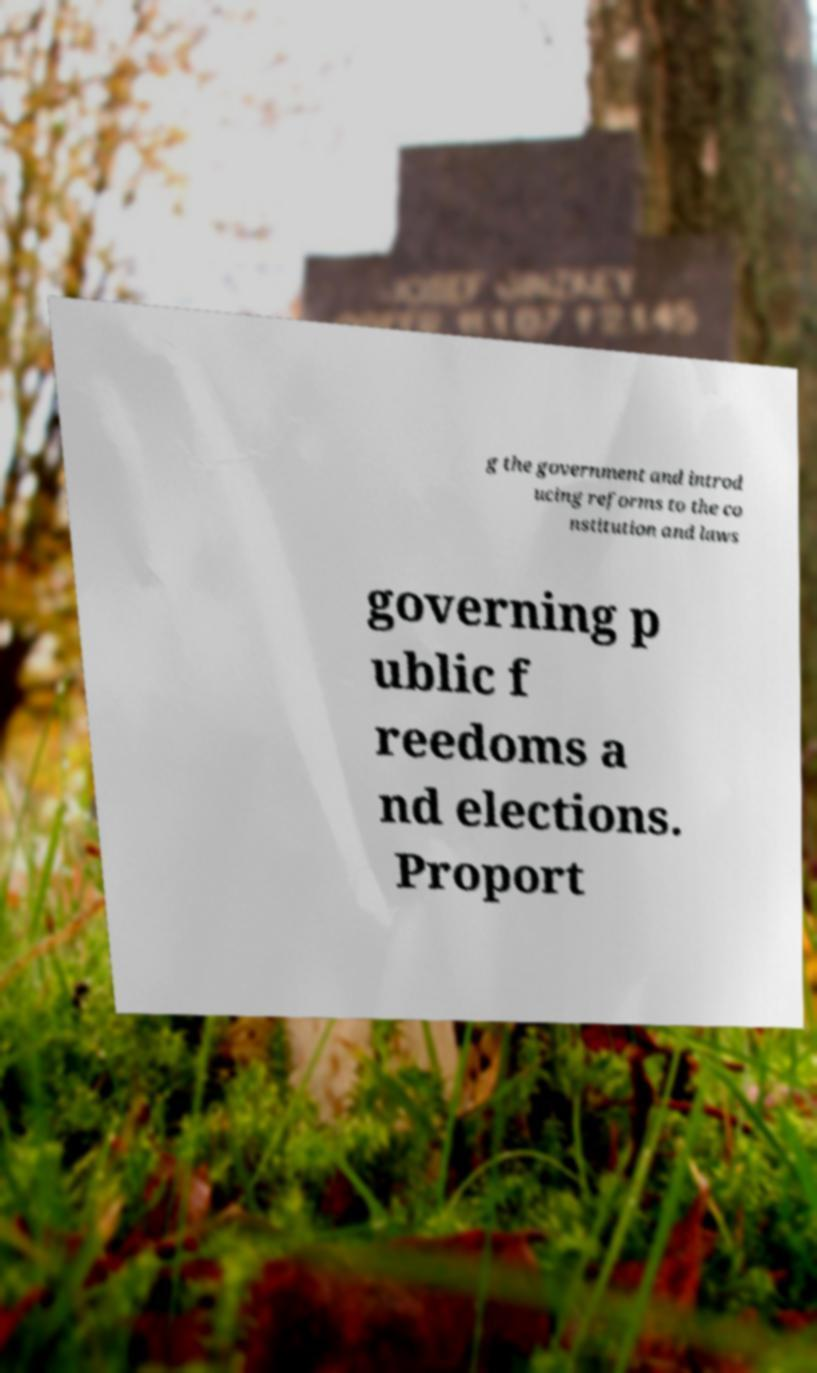For documentation purposes, I need the text within this image transcribed. Could you provide that? g the government and introd ucing reforms to the co nstitution and laws governing p ublic f reedoms a nd elections. Proport 